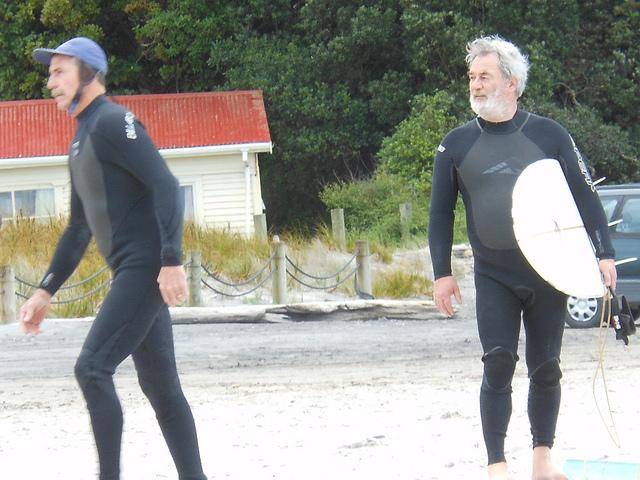Where do these men want to go next? Please explain your reasoning. ocean. The men are in wetsuits and one is holding a skateboard. this equipment would be traditional employed in the ocean if it were to be used correctly. 